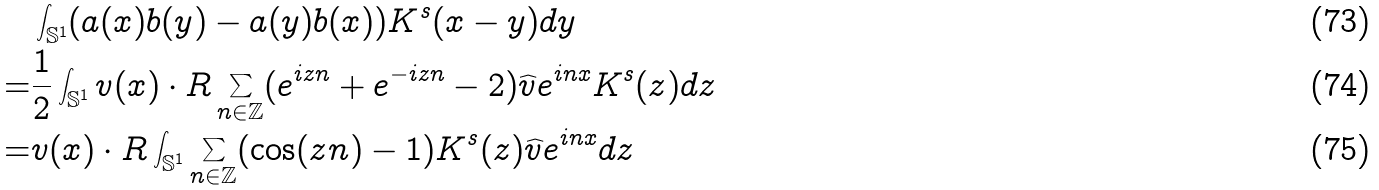Convert formula to latex. <formula><loc_0><loc_0><loc_500><loc_500>& \int _ { \mathbb { S } ^ { 1 } } ( a ( x ) b ( y ) - a ( y ) b ( x ) ) K ^ { s } ( x - y ) d y \\ = & \frac { 1 } { 2 } \int _ { \mathbb { S } ^ { 1 } } v ( x ) \cdot R \sum _ { n \in \mathbb { Z } } ( e ^ { i z n } + e ^ { - i z n } - 2 ) \widehat { v } e ^ { i n x } K ^ { s } ( z ) d z \\ = & v ( x ) \cdot R \int _ { \mathbb { S } ^ { 1 } } \sum _ { n \in \mathbb { Z } } ( \cos ( z n ) - 1 ) K ^ { s } ( z ) \widehat { v } e ^ { i n x } d z</formula> 